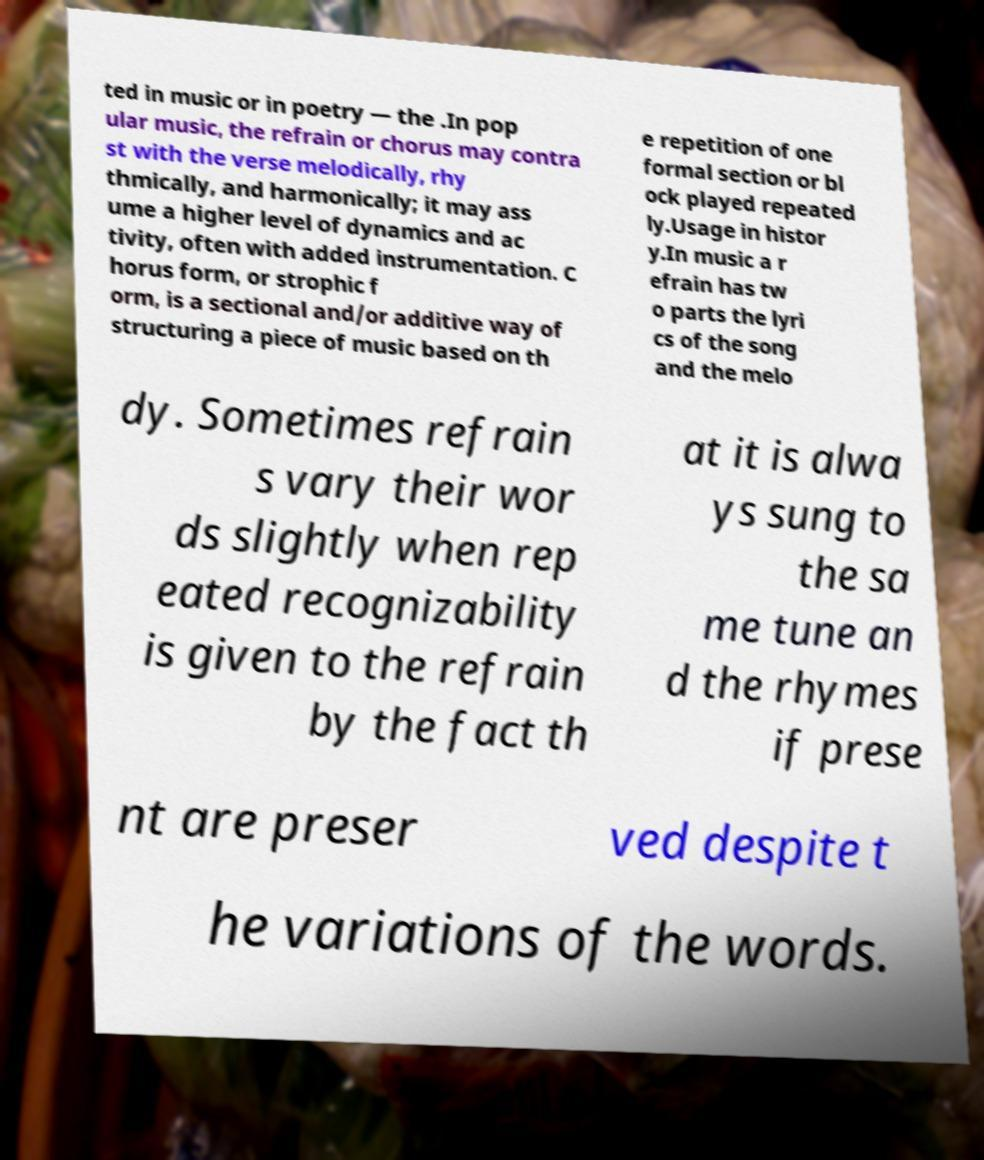I need the written content from this picture converted into text. Can you do that? ted in music or in poetry — the .In pop ular music, the refrain or chorus may contra st with the verse melodically, rhy thmically, and harmonically; it may ass ume a higher level of dynamics and ac tivity, often with added instrumentation. C horus form, or strophic f orm, is a sectional and/or additive way of structuring a piece of music based on th e repetition of one formal section or bl ock played repeated ly.Usage in histor y.In music a r efrain has tw o parts the lyri cs of the song and the melo dy. Sometimes refrain s vary their wor ds slightly when rep eated recognizability is given to the refrain by the fact th at it is alwa ys sung to the sa me tune an d the rhymes if prese nt are preser ved despite t he variations of the words. 